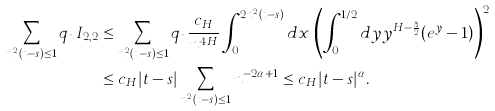<formula> <loc_0><loc_0><loc_500><loc_500>\sum _ { n ^ { 2 } ( t - s ) \leq 1 } q _ { n } I _ { 2 , 2 } & \leq \sum _ { n ^ { 2 } ( t - s ) \leq 1 } q _ { n } \frac { c _ { H } } { n ^ { 4 H } } \int _ { 0 } ^ { 2 n ^ { 2 } ( t - s ) } d x \, \left ( \int _ { 0 } ^ { 1 / 2 } d y y ^ { H - \frac { 3 } { 2 } } ( e ^ { y } - 1 ) \right ) ^ { 2 } \\ & \leq c _ { H } | t - s | \sum _ { n ^ { 2 } ( t - s ) \leq 1 } n ^ { - 2 \alpha + 1 } \leq c _ { H } | t - s | ^ { \alpha } .</formula> 